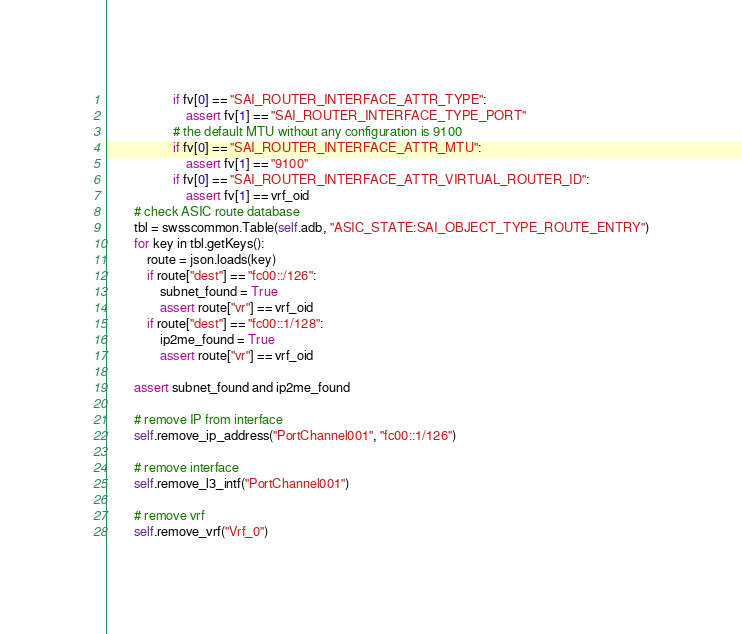<code> <loc_0><loc_0><loc_500><loc_500><_Python_>                    if fv[0] == "SAI_ROUTER_INTERFACE_ATTR_TYPE":
                        assert fv[1] == "SAI_ROUTER_INTERFACE_TYPE_PORT"
                    # the default MTU without any configuration is 9100
                    if fv[0] == "SAI_ROUTER_INTERFACE_ATTR_MTU":
                        assert fv[1] == "9100"
                    if fv[0] == "SAI_ROUTER_INTERFACE_ATTR_VIRTUAL_ROUTER_ID":
                        assert fv[1] == vrf_oid
        # check ASIC route database
        tbl = swsscommon.Table(self.adb, "ASIC_STATE:SAI_OBJECT_TYPE_ROUTE_ENTRY")
        for key in tbl.getKeys():
            route = json.loads(key)
            if route["dest"] == "fc00::/126":
                subnet_found = True
                assert route["vr"] == vrf_oid
            if route["dest"] == "fc00::1/128":
                ip2me_found = True
                assert route["vr"] == vrf_oid

        assert subnet_found and ip2me_found

        # remove IP from interface
        self.remove_ip_address("PortChannel001", "fc00::1/126")

        # remove interface
        self.remove_l3_intf("PortChannel001")

        # remove vrf
        self.remove_vrf("Vrf_0")
</code> 